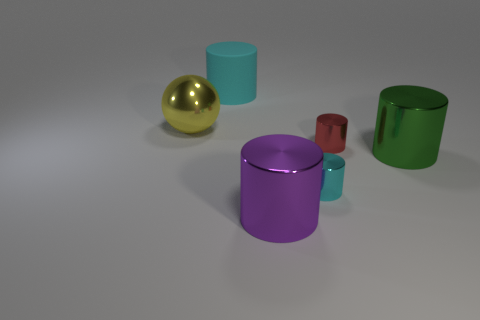Subtract all large purple cylinders. How many cylinders are left? 4 Subtract all gray spheres. How many cyan cylinders are left? 2 Subtract all cyan cylinders. How many cylinders are left? 3 Add 1 red matte objects. How many objects exist? 7 Subtract all balls. How many objects are left? 5 Subtract all red balls. Subtract all green cylinders. How many balls are left? 1 Subtract all small cylinders. Subtract all tiny gray shiny cylinders. How many objects are left? 4 Add 3 big cylinders. How many big cylinders are left? 6 Add 3 big green things. How many big green things exist? 4 Subtract 0 brown spheres. How many objects are left? 6 